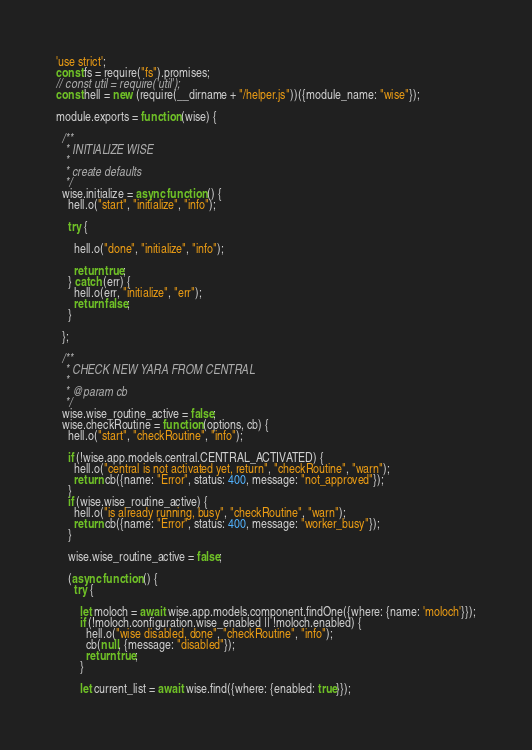Convert code to text. <code><loc_0><loc_0><loc_500><loc_500><_JavaScript_>'use strict';
const fs = require("fs").promises;
// const util = require('util');
const hell = new (require(__dirname + "/helper.js"))({module_name: "wise"});

module.exports = function (wise) {

  /**
   * INITIALIZE WISE
   *
   * create defaults
   */
  wise.initialize = async function () {
    hell.o("start", "initialize", "info");

    try {

      hell.o("done", "initialize", "info");

      return true;
    } catch (err) {
      hell.o(err, "initialize", "err");
      return false;
    }

  };

  /**
   * CHECK NEW YARA FROM CENTRAL
   *
   * @param cb
   */
  wise.wise_routine_active = false;
  wise.checkRoutine = function (options, cb) {
    hell.o("start", "checkRoutine", "info");

    if (!wise.app.models.central.CENTRAL_ACTIVATED) {
      hell.o("central is not activated yet, return", "checkRoutine", "warn");
      return cb({name: "Error", status: 400, message: "not_approved"});
    }
    if (wise.wise_routine_active) {
      hell.o("is already running, busy", "checkRoutine", "warn");
      return cb({name: "Error", status: 400, message: "worker_busy"});
    }

    wise.wise_routine_active = false;

    (async function () {
      try {

        let moloch = await wise.app.models.component.findOne({where: {name: 'moloch'}});
        if (!moloch.configuration.wise_enabled || !moloch.enabled) {
          hell.o("wise disabled, done", "checkRoutine", "info");
          cb(null, {message: "disabled"});
          return true;
        }

        let current_list = await wise.find({where: {enabled: true}});</code> 